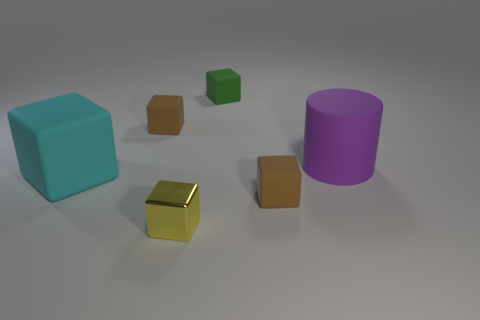Subtract all rubber cubes. How many cubes are left? 1 Subtract all brown cylinders. How many brown blocks are left? 2 Add 3 small purple matte cylinders. How many objects exist? 9 Subtract all green cubes. How many cubes are left? 4 Subtract all cubes. How many objects are left? 1 Subtract 1 blocks. How many blocks are left? 4 Subtract all blue blocks. Subtract all gray cylinders. How many blocks are left? 5 Subtract all large yellow matte blocks. Subtract all purple matte objects. How many objects are left? 5 Add 1 big things. How many big things are left? 3 Add 4 yellow metal blocks. How many yellow metal blocks exist? 5 